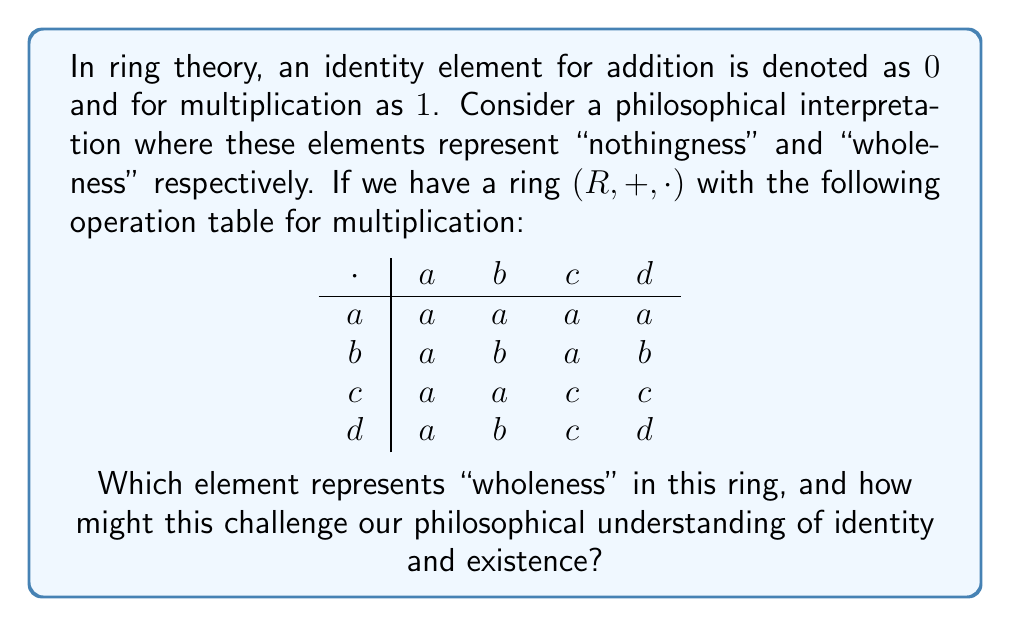Can you solve this math problem? To solve this problem, we need to follow these steps:

1) Recall the definition of an identity element for multiplication in a ring: For all elements $x$ in the ring, $1 \cdot x = x \cdot 1 = x$.

2) Examine the multiplication table:
   - For element $a$: $a \cdot a = a$, $a \cdot b = a$, $a \cdot c = a$, $a \cdot d = a$
   - For element $b$: $b \cdot a = a$, $b \cdot b = b$, $b \cdot c = a$, $b \cdot d = b$
   - For element $c$: $c \cdot a = a$, $c \cdot b = a$, $c \cdot c = c$, $c \cdot d = c$
   - For element $d$: $d \cdot a = a$, $d \cdot b = b$, $d \cdot c = c$, $d \cdot d = d$

3) We see that only element $d$ satisfies the condition for being the multiplicative identity: when multiplied by any element, it returns that element.

4) Philosophical Implications:
   - The element $d$ represents "wholeness" in this ring.
   - This challenges our intuitive understanding of identity and existence because:
     a) The "whole" ($d$) is not the only element that, when multiplied by itself, yields itself (note $a \cdot a = a$, $b \cdot b = b$, $c \cdot c = c$).
     b) The other elements ($a$, $b$, $c$) exhibit a form of "absorption" into each other or themselves, which could be interpreted as a loss of individual identity.
     c) The concept of "wholeness" ($d$) in this ring doesn't create or amplify other elements, it merely preserves them, which might challenge our notions of the relationship between "the whole" and its parts.

This mathematical structure provides a unique lens through which we can examine philosophical concepts of identity, wholeness, and the nature of existence.
Answer: $d$ represents "wholeness", challenging notions of identity and whole-part relations. 